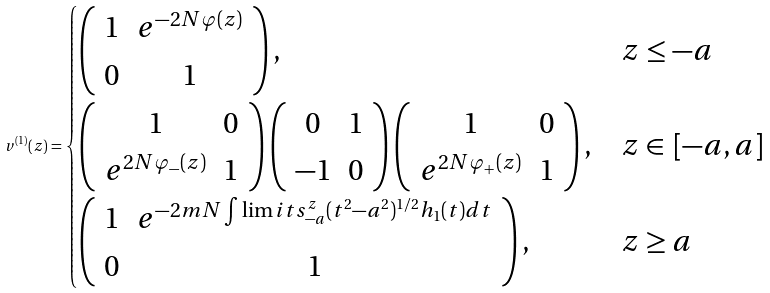<formula> <loc_0><loc_0><loc_500><loc_500>v ^ { ( 1 ) } ( z ) = \begin{cases} \left ( \begin{array} { c c } 1 & e ^ { - 2 N \varphi ( z ) } \\ 0 & 1 \\ \end{array} \right ) , & z \leq - a \\ \left ( \begin{array} { c c } 1 & 0 \\ e ^ { 2 N \varphi _ { - } ( z ) } & 1 \end{array} \right ) \left ( \begin{array} { c c } 0 & 1 \\ - 1 & 0 \end{array} \right ) \left ( \begin{array} { c c } 1 & 0 \\ e ^ { 2 N \varphi _ { + } ( z ) } & 1 \end{array} \right ) , & z \in \, [ - a , a ] \\ \left ( \begin{array} { c c } 1 & e ^ { - 2 m N \int \lim i t s _ { - a } ^ { z } ( t ^ { 2 } - a ^ { 2 } ) ^ { 1 / 2 } h _ { 1 } ( t ) d t } \\ 0 & 1 \\ \end{array} \right ) , & z \geq a \end{cases}</formula> 